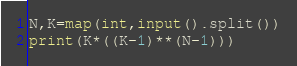<code> <loc_0><loc_0><loc_500><loc_500><_Python_>N,K=map(int,input().split())
print(K*((K-1)**(N-1)))
</code> 